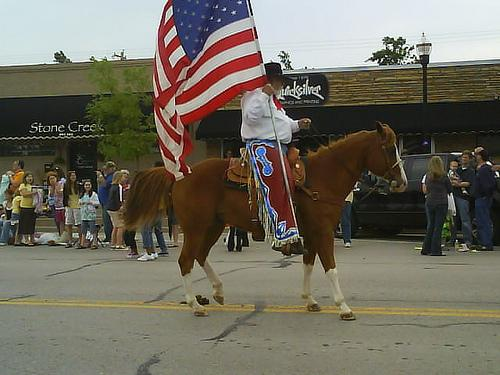What are the white marks on the horse's legs called?

Choices:
A) boots
B) shoes
C) leggings
D) socks socks 